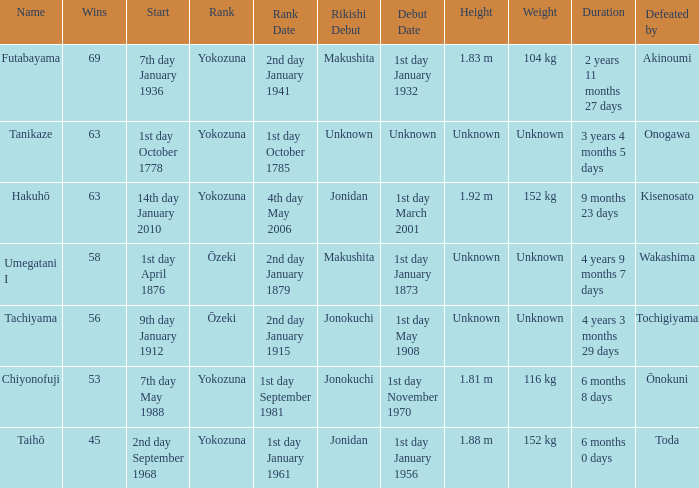What is the Duration for less than 53 consecutive wins? 6 months 0 days. 